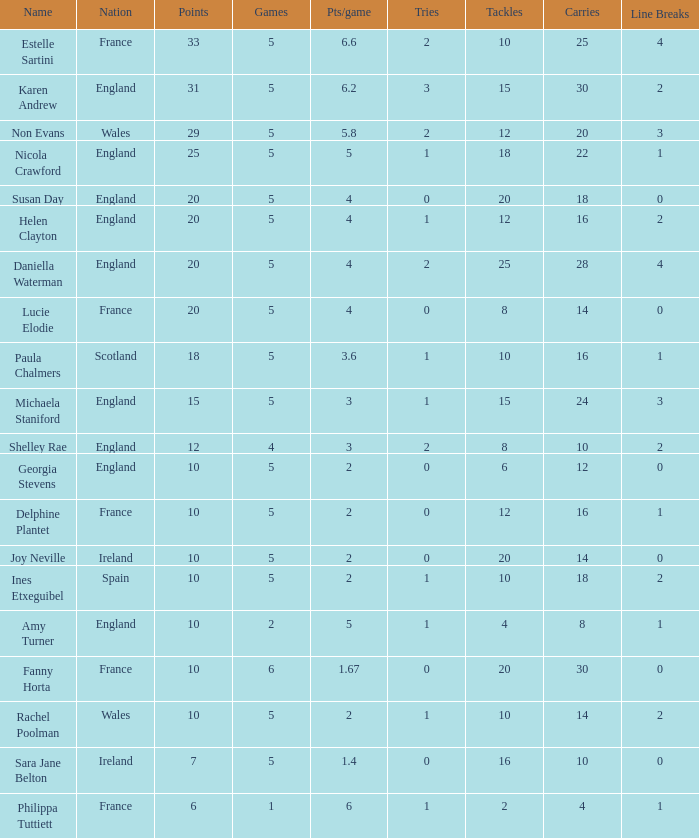Can you tell me the average Points that has a Pts/game larger than 4, and the Nation of england, and the Games smaller than 5? 10.0. 